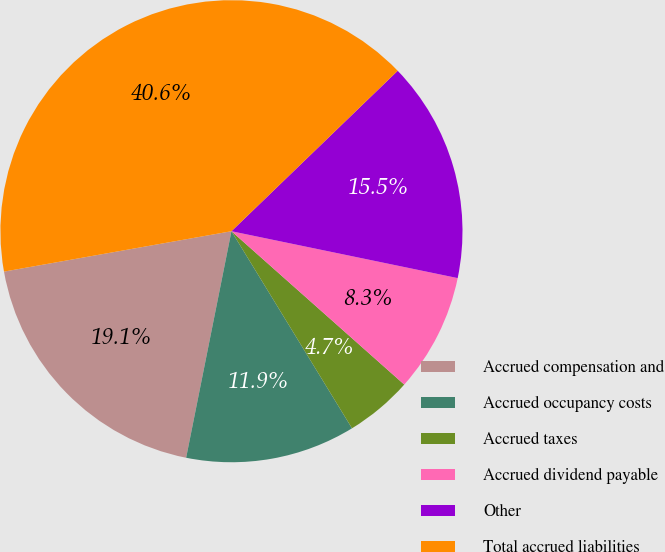Convert chart to OTSL. <chart><loc_0><loc_0><loc_500><loc_500><pie_chart><fcel>Accrued compensation and<fcel>Accrued occupancy costs<fcel>Accrued taxes<fcel>Accrued dividend payable<fcel>Other<fcel>Total accrued liabilities<nl><fcel>19.06%<fcel>11.88%<fcel>4.71%<fcel>8.3%<fcel>15.47%<fcel>40.58%<nl></chart> 